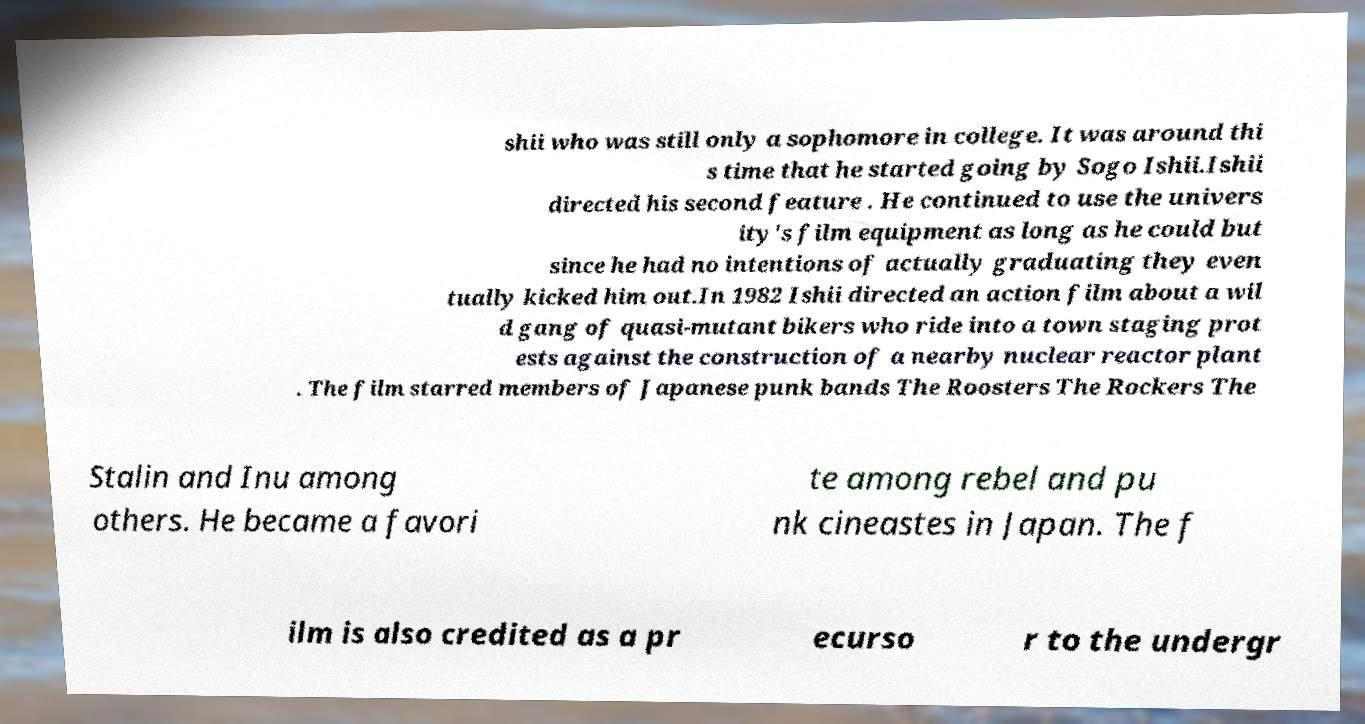Please identify and transcribe the text found in this image. shii who was still only a sophomore in college. It was around thi s time that he started going by Sogo Ishii.Ishii directed his second feature . He continued to use the univers ity's film equipment as long as he could but since he had no intentions of actually graduating they even tually kicked him out.In 1982 Ishii directed an action film about a wil d gang of quasi-mutant bikers who ride into a town staging prot ests against the construction of a nearby nuclear reactor plant . The film starred members of Japanese punk bands The Roosters The Rockers The Stalin and Inu among others. He became a favori te among rebel and pu nk cineastes in Japan. The f ilm is also credited as a pr ecurso r to the undergr 